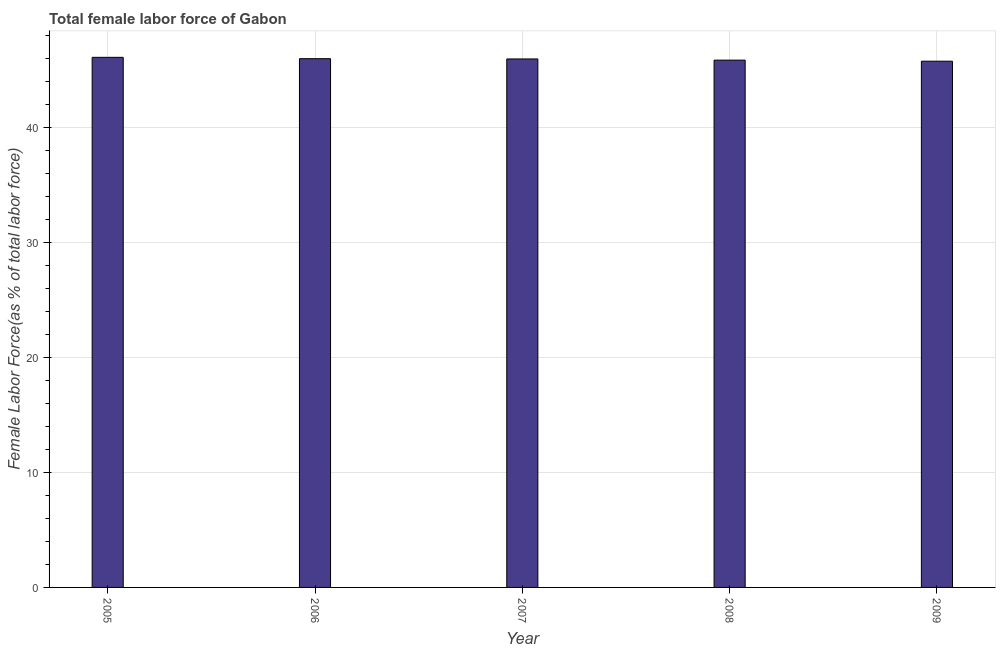What is the title of the graph?
Provide a short and direct response. Total female labor force of Gabon. What is the label or title of the Y-axis?
Offer a very short reply. Female Labor Force(as % of total labor force). What is the total female labor force in 2005?
Offer a very short reply. 46.13. Across all years, what is the maximum total female labor force?
Make the answer very short. 46.13. Across all years, what is the minimum total female labor force?
Offer a very short reply. 45.8. In which year was the total female labor force maximum?
Ensure brevity in your answer.  2005. In which year was the total female labor force minimum?
Offer a terse response. 2009. What is the sum of the total female labor force?
Offer a very short reply. 229.84. What is the difference between the total female labor force in 2007 and 2009?
Your answer should be very brief. 0.2. What is the average total female labor force per year?
Ensure brevity in your answer.  45.97. What is the median total female labor force?
Your answer should be very brief. 45.99. What is the difference between the highest and the second highest total female labor force?
Provide a short and direct response. 0.12. Is the sum of the total female labor force in 2005 and 2009 greater than the maximum total female labor force across all years?
Offer a terse response. Yes. What is the difference between the highest and the lowest total female labor force?
Provide a succinct answer. 0.34. Are all the bars in the graph horizontal?
Your answer should be compact. No. What is the Female Labor Force(as % of total labor force) of 2005?
Your answer should be compact. 46.13. What is the Female Labor Force(as % of total labor force) in 2006?
Offer a terse response. 46.02. What is the Female Labor Force(as % of total labor force) in 2007?
Your answer should be compact. 45.99. What is the Female Labor Force(as % of total labor force) of 2008?
Provide a succinct answer. 45.89. What is the Female Labor Force(as % of total labor force) of 2009?
Your response must be concise. 45.8. What is the difference between the Female Labor Force(as % of total labor force) in 2005 and 2006?
Offer a very short reply. 0.12. What is the difference between the Female Labor Force(as % of total labor force) in 2005 and 2007?
Keep it short and to the point. 0.14. What is the difference between the Female Labor Force(as % of total labor force) in 2005 and 2008?
Provide a short and direct response. 0.24. What is the difference between the Female Labor Force(as % of total labor force) in 2005 and 2009?
Keep it short and to the point. 0.34. What is the difference between the Female Labor Force(as % of total labor force) in 2006 and 2007?
Make the answer very short. 0.02. What is the difference between the Female Labor Force(as % of total labor force) in 2006 and 2008?
Your answer should be compact. 0.13. What is the difference between the Female Labor Force(as % of total labor force) in 2006 and 2009?
Keep it short and to the point. 0.22. What is the difference between the Female Labor Force(as % of total labor force) in 2007 and 2008?
Give a very brief answer. 0.1. What is the difference between the Female Labor Force(as % of total labor force) in 2007 and 2009?
Offer a terse response. 0.2. What is the difference between the Female Labor Force(as % of total labor force) in 2008 and 2009?
Provide a short and direct response. 0.09. What is the ratio of the Female Labor Force(as % of total labor force) in 2005 to that in 2006?
Offer a very short reply. 1. What is the ratio of the Female Labor Force(as % of total labor force) in 2005 to that in 2009?
Provide a short and direct response. 1.01. What is the ratio of the Female Labor Force(as % of total labor force) in 2006 to that in 2008?
Ensure brevity in your answer.  1. What is the ratio of the Female Labor Force(as % of total labor force) in 2006 to that in 2009?
Provide a succinct answer. 1. 